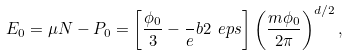Convert formula to latex. <formula><loc_0><loc_0><loc_500><loc_500>E _ { 0 } = \mu N - P _ { 0 } = \left [ \frac { \phi _ { 0 } } 3 - \frac { \ } { e } b { 2 \ e p s } \right ] \left ( \frac { m \phi _ { 0 } } { 2 \pi } \right ) ^ { d / 2 } ,</formula> 